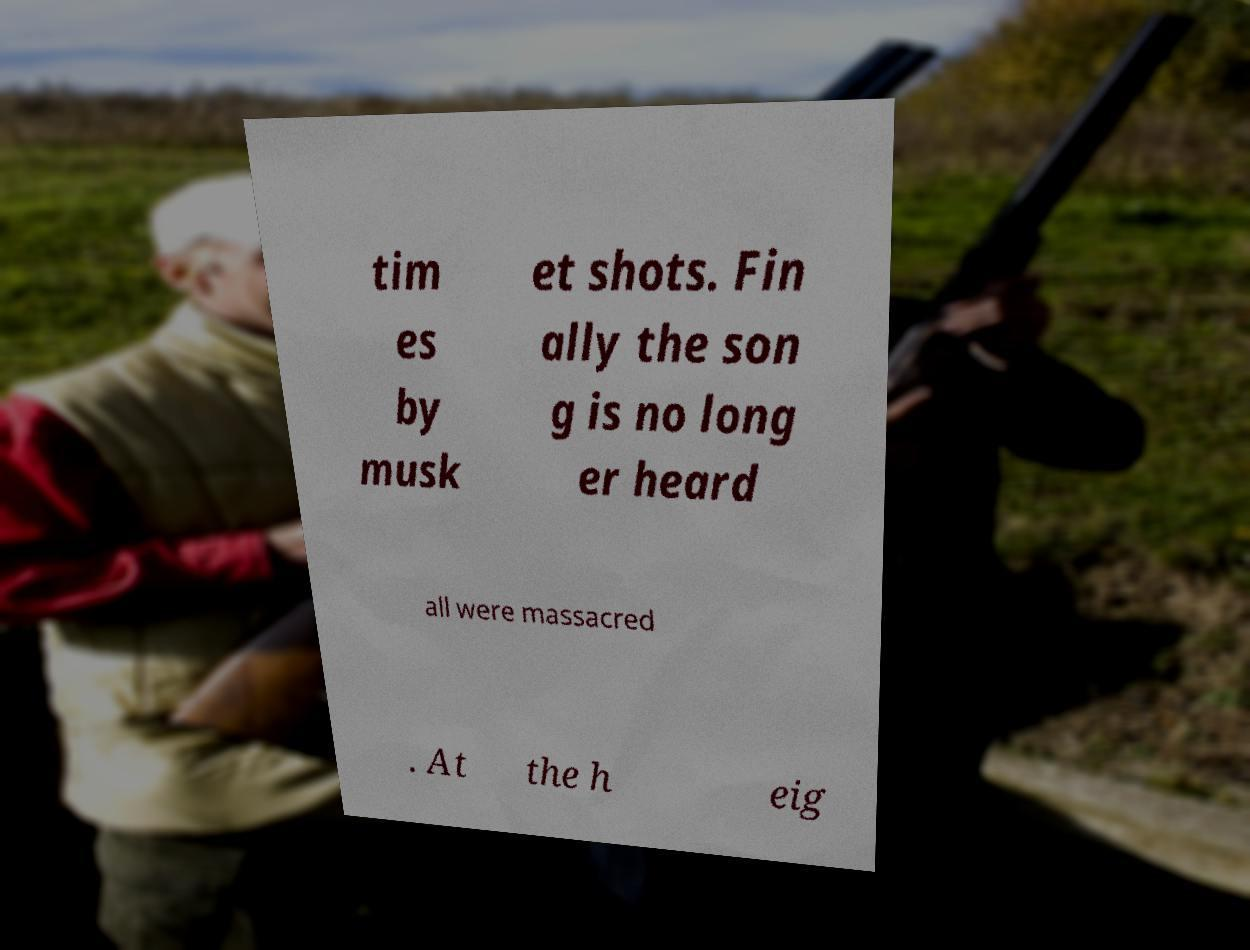Could you assist in decoding the text presented in this image and type it out clearly? tim es by musk et shots. Fin ally the son g is no long er heard all were massacred . At the h eig 